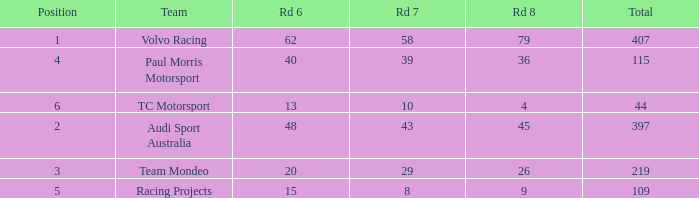What is the sum of total values for Rd 7 less than 8? None. 